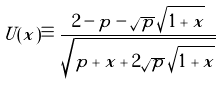<formula> <loc_0><loc_0><loc_500><loc_500>U ( x ) \equiv \frac { 2 - p - \sqrt { p } \, \sqrt { 1 + x } } { \sqrt { p + x + 2 \sqrt { p } \, \sqrt { 1 + x } } }</formula> 